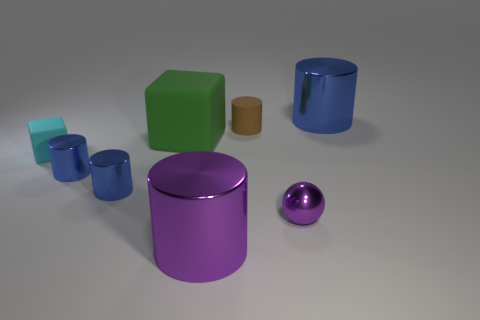Is there a object that has the same color as the sphere?
Ensure brevity in your answer.  Yes. There is a small brown object; what number of purple metal cylinders are in front of it?
Your response must be concise. 1. What number of large purple objects are there?
Your response must be concise. 1. Do the green rubber object and the purple shiny cylinder have the same size?
Make the answer very short. Yes. Are there any tiny blue metal things on the left side of the blue cylinder right of the big metal cylinder that is to the left of the large blue metal thing?
Provide a succinct answer. Yes. What is the material of the other small thing that is the same shape as the green object?
Your answer should be compact. Rubber. There is a metallic cylinder that is behind the green cube; what color is it?
Provide a succinct answer. Blue. What is the size of the brown matte cylinder?
Your answer should be very brief. Small. Is the size of the matte cylinder the same as the cyan rubber thing that is in front of the large green rubber cube?
Your answer should be compact. Yes. There is a big cylinder that is to the left of the metallic cylinder to the right of the shiny cylinder that is in front of the purple metallic sphere; what color is it?
Your response must be concise. Purple. 